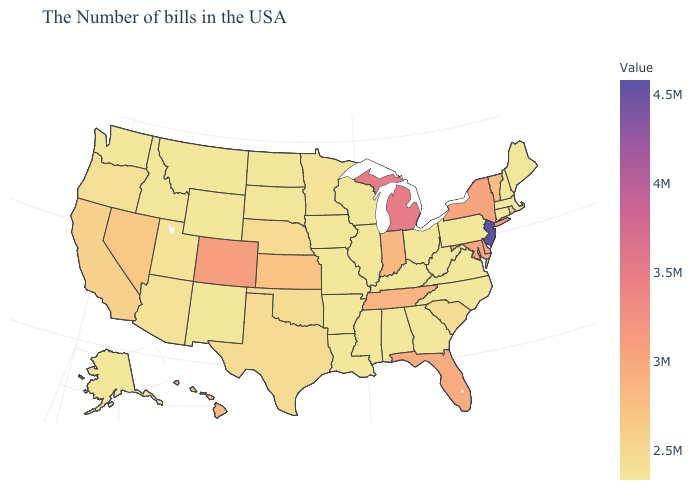Among the states that border Vermont , which have the lowest value?
Concise answer only. Massachusetts, New Hampshire. Which states have the highest value in the USA?
Be succinct. New Jersey. Does Mississippi have the lowest value in the South?
Keep it brief. Yes. Does Kansas have a lower value than Arkansas?
Short answer required. No. Does Kentucky have the lowest value in the USA?
Be succinct. Yes. Which states have the highest value in the USA?
Concise answer only. New Jersey. 